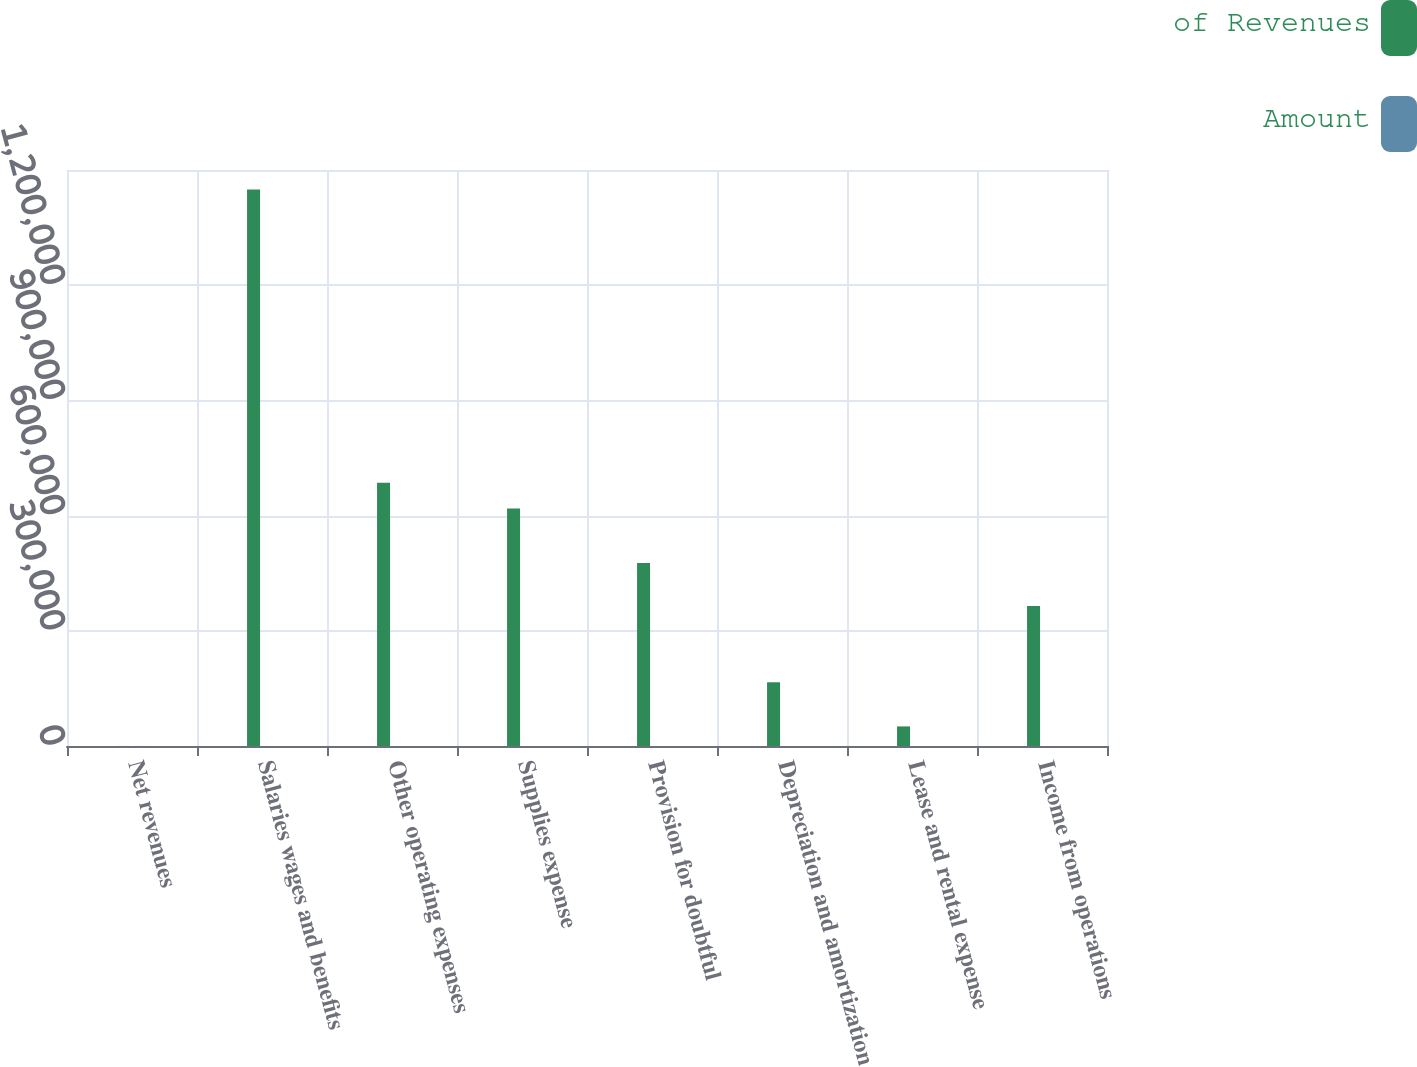Convert chart. <chart><loc_0><loc_0><loc_500><loc_500><stacked_bar_chart><ecel><fcel>Net revenues<fcel>Salaries wages and benefits<fcel>Other operating expenses<fcel>Supplies expense<fcel>Provision for doubtful<fcel>Depreciation and amortization<fcel>Lease and rental expense<fcel>Income from operations<nl><fcel>of Revenues<fcel>100<fcel>1.44918e+06<fcel>685529<fcel>618321<fcel>476408<fcel>165967<fcel>51035<fcel>364385<nl><fcel>Amount<fcel>100<fcel>38<fcel>18<fcel>16.2<fcel>12.5<fcel>4.4<fcel>1.3<fcel>9.6<nl></chart> 